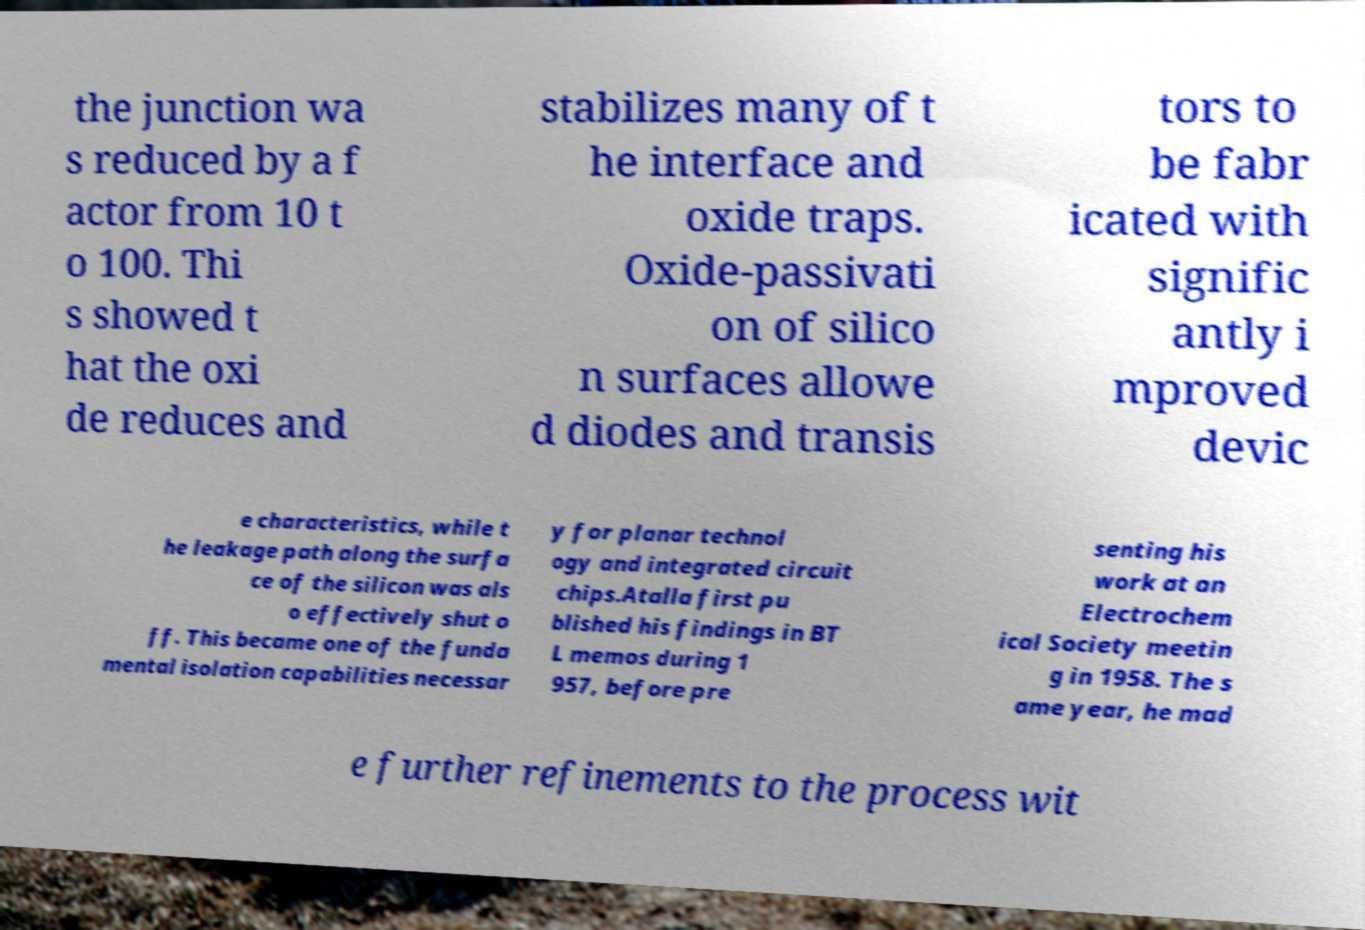Can you accurately transcribe the text from the provided image for me? the junction wa s reduced by a f actor from 10 t o 100. Thi s showed t hat the oxi de reduces and stabilizes many of t he interface and oxide traps. Oxide-passivati on of silico n surfaces allowe d diodes and transis tors to be fabr icated with signific antly i mproved devic e characteristics, while t he leakage path along the surfa ce of the silicon was als o effectively shut o ff. This became one of the funda mental isolation capabilities necessar y for planar technol ogy and integrated circuit chips.Atalla first pu blished his findings in BT L memos during 1 957, before pre senting his work at an Electrochem ical Society meetin g in 1958. The s ame year, he mad e further refinements to the process wit 